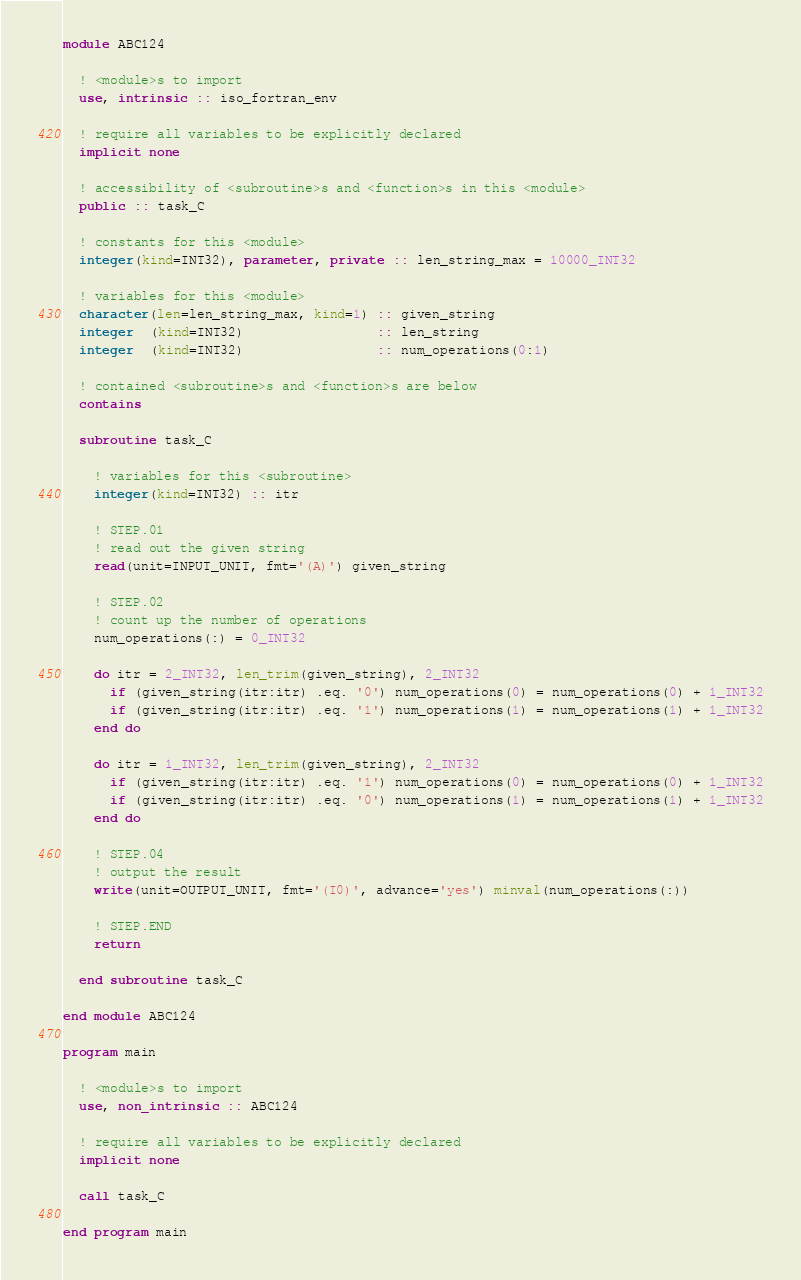<code> <loc_0><loc_0><loc_500><loc_500><_FORTRAN_>module ABC124

  ! <module>s to import
  use, intrinsic :: iso_fortran_env

  ! require all variables to be explicitly declared
  implicit none

  ! accessibility of <subroutine>s and <function>s in this <module>
  public :: task_C

  ! constants for this <module>
  integer(kind=INT32), parameter, private :: len_string_max = 10000_INT32

  ! variables for this <module>
  character(len=len_string_max, kind=1) :: given_string
  integer  (kind=INT32)                 :: len_string
  integer  (kind=INT32)                 :: num_operations(0:1)

  ! contained <subroutine>s and <function>s are below
  contains

  subroutine task_C

    ! variables for this <subroutine>
    integer(kind=INT32) :: itr

    ! STEP.01
    ! read out the given string
    read(unit=INPUT_UNIT, fmt='(A)') given_string

    ! STEP.02
    ! count up the number of operations
    num_operations(:) = 0_INT32

    do itr = 2_INT32, len_trim(given_string), 2_INT32
      if (given_string(itr:itr) .eq. '0') num_operations(0) = num_operations(0) + 1_INT32
      if (given_string(itr:itr) .eq. '1') num_operations(1) = num_operations(1) + 1_INT32
    end do

    do itr = 1_INT32, len_trim(given_string), 2_INT32
      if (given_string(itr:itr) .eq. '1') num_operations(0) = num_operations(0) + 1_INT32
      if (given_string(itr:itr) .eq. '0') num_operations(1) = num_operations(1) + 1_INT32
    end do

    ! STEP.04
    ! output the result
    write(unit=OUTPUT_UNIT, fmt='(I0)', advance='yes') minval(num_operations(:))

    ! STEP.END
    return

  end subroutine task_C

end module ABC124

program main

  ! <module>s to import
  use, non_intrinsic :: ABC124

  ! require all variables to be explicitly declared
  implicit none

  call task_C

end program main</code> 